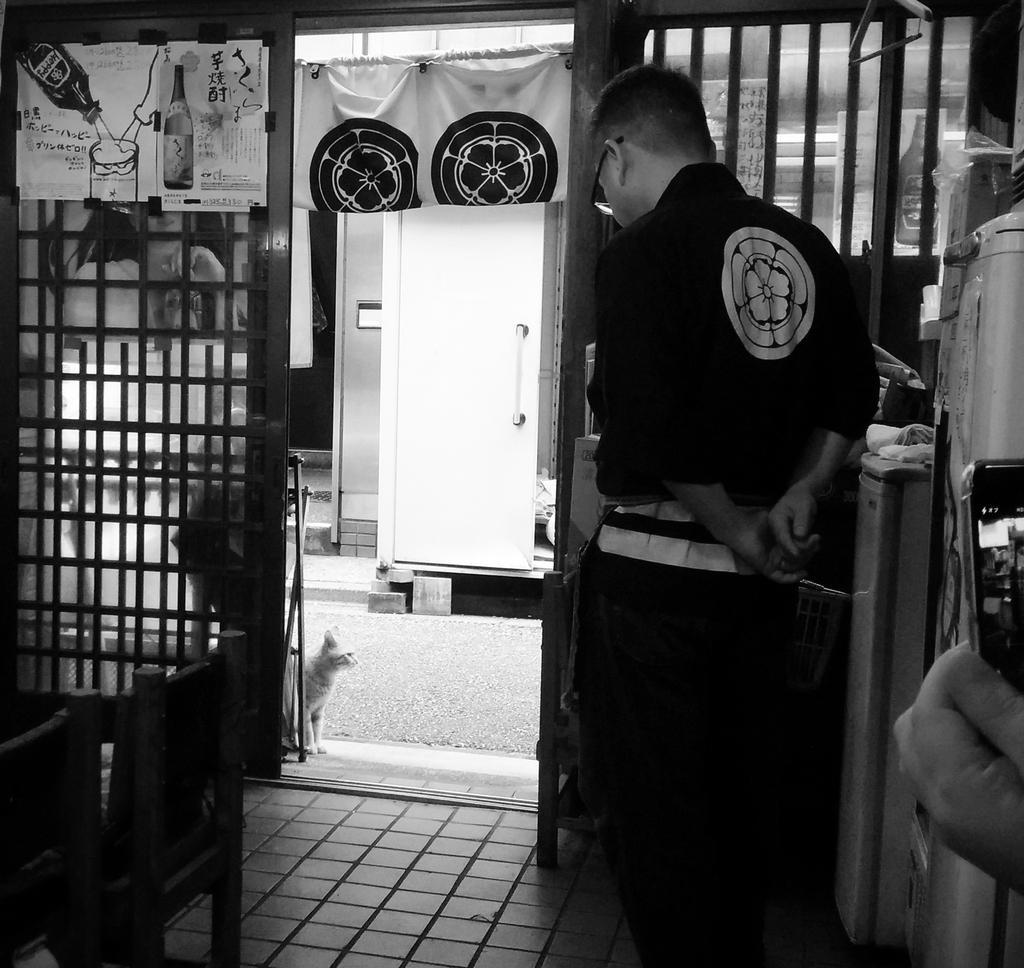Could you give a brief overview of what you see in this image? In this picture I can see a person standing in side the room, side we can see some chairs, refrigerators, boxes, in front we can see a cat at the entrances, we can see a fencing wall. 